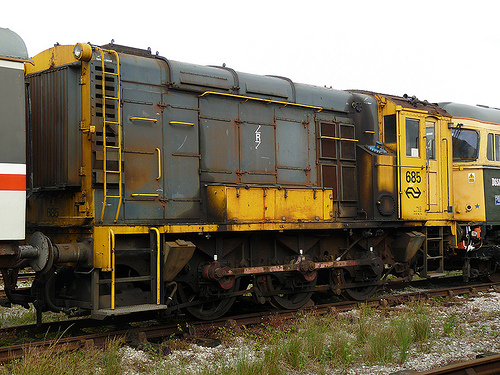Suppose there’s a hidden treasure in this image, where would it be and what would it be? A hidden treasure in this image could be concealed within the compartments or under the floorboards of the train car itself. It could be an old, forgotten chest containing valuable historical documents, antique coins, or even a mysterious artifact from a bygone era, waiting to be discovered by an intrepid explorer or an unsuspecting railway worker. Create a cinematic scene involving the train cars. The scene opens with a panoramic shot of a desolate railway yard at dawn, shrouded in mist. The camera zooms in on the old, weathered train car with the numbers '685' etched on its side. As the haunting sounds of a distant train echo in the background, a young, determined woman, dressed in 1940s attire, sneaks into the yard. She is on a quest to find a hidden clue believed to be inside the train car. The camera follows her as she skillfully picks the lock and climbs aboard, her lantern casting eerie shadows on the rusty interior. As she searches, she narrowly avoids detection by a patrolling guard. Finally, she discovers an ancient map hidden beneath a loose floorboard, revealing the location of a forgotten treasure. The scene ends with her looking triumphant, yet wary, as she prepares for the next part of her perilous journey. 